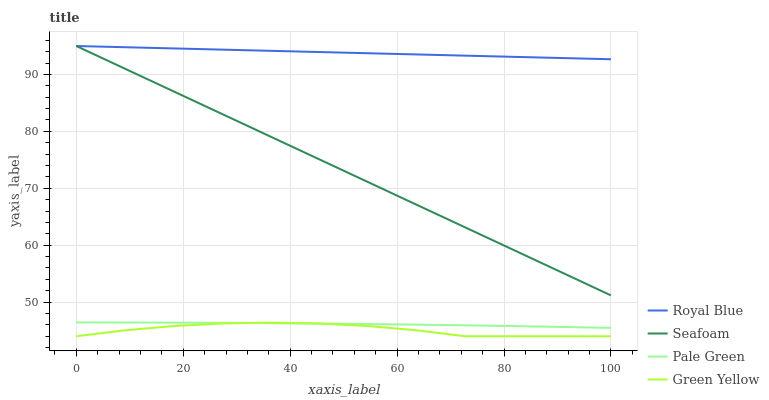Does Green Yellow have the minimum area under the curve?
Answer yes or no. Yes. Does Royal Blue have the maximum area under the curve?
Answer yes or no. Yes. Does Pale Green have the minimum area under the curve?
Answer yes or no. No. Does Pale Green have the maximum area under the curve?
Answer yes or no. No. Is Royal Blue the smoothest?
Answer yes or no. Yes. Is Green Yellow the roughest?
Answer yes or no. Yes. Is Pale Green the smoothest?
Answer yes or no. No. Is Pale Green the roughest?
Answer yes or no. No. Does Green Yellow have the lowest value?
Answer yes or no. Yes. Does Pale Green have the lowest value?
Answer yes or no. No. Does Seafoam have the highest value?
Answer yes or no. Yes. Does Pale Green have the highest value?
Answer yes or no. No. Is Pale Green less than Seafoam?
Answer yes or no. Yes. Is Seafoam greater than Green Yellow?
Answer yes or no. Yes. Does Green Yellow intersect Pale Green?
Answer yes or no. Yes. Is Green Yellow less than Pale Green?
Answer yes or no. No. Is Green Yellow greater than Pale Green?
Answer yes or no. No. Does Pale Green intersect Seafoam?
Answer yes or no. No. 